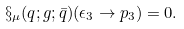<formula> <loc_0><loc_0><loc_500><loc_500>\S _ { \mu } ( q ; g ; \bar { q } ) ( \epsilon _ { 3 } \to p _ { 3 } ) = 0 .</formula> 